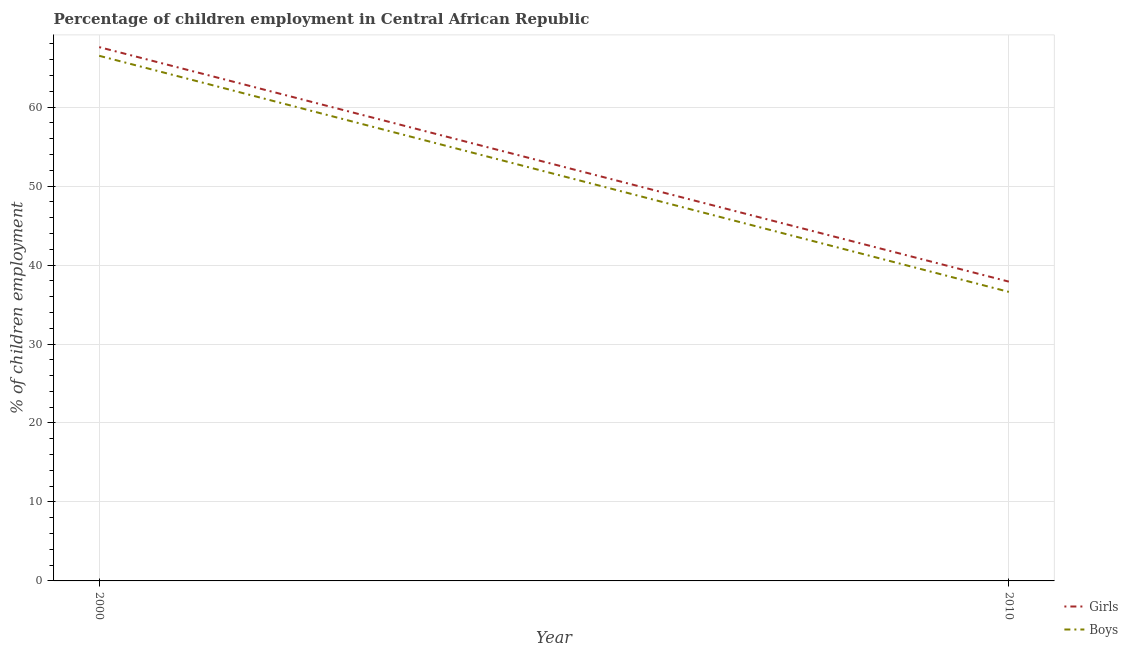How many different coloured lines are there?
Give a very brief answer. 2. Does the line corresponding to percentage of employed boys intersect with the line corresponding to percentage of employed girls?
Give a very brief answer. No. Is the number of lines equal to the number of legend labels?
Ensure brevity in your answer.  Yes. What is the percentage of employed boys in 2010?
Your answer should be very brief. 36.6. Across all years, what is the maximum percentage of employed boys?
Keep it short and to the point. 66.5. Across all years, what is the minimum percentage of employed boys?
Your response must be concise. 36.6. In which year was the percentage of employed boys maximum?
Offer a very short reply. 2000. In which year was the percentage of employed girls minimum?
Offer a very short reply. 2010. What is the total percentage of employed girls in the graph?
Provide a short and direct response. 105.5. What is the difference between the percentage of employed boys in 2000 and that in 2010?
Make the answer very short. 29.9. What is the difference between the percentage of employed girls in 2010 and the percentage of employed boys in 2000?
Your response must be concise. -28.6. What is the average percentage of employed girls per year?
Provide a succinct answer. 52.75. In the year 2010, what is the difference between the percentage of employed boys and percentage of employed girls?
Keep it short and to the point. -1.3. What is the ratio of the percentage of employed boys in 2000 to that in 2010?
Offer a very short reply. 1.82. Does the percentage of employed boys monotonically increase over the years?
Make the answer very short. No. How many years are there in the graph?
Give a very brief answer. 2. What is the difference between two consecutive major ticks on the Y-axis?
Offer a terse response. 10. Does the graph contain grids?
Offer a terse response. Yes. Where does the legend appear in the graph?
Keep it short and to the point. Bottom right. How many legend labels are there?
Provide a succinct answer. 2. What is the title of the graph?
Ensure brevity in your answer.  Percentage of children employment in Central African Republic. What is the label or title of the X-axis?
Provide a short and direct response. Year. What is the label or title of the Y-axis?
Offer a very short reply. % of children employment. What is the % of children employment of Girls in 2000?
Ensure brevity in your answer.  67.6. What is the % of children employment of Boys in 2000?
Provide a short and direct response. 66.5. What is the % of children employment of Girls in 2010?
Give a very brief answer. 37.9. What is the % of children employment in Boys in 2010?
Ensure brevity in your answer.  36.6. Across all years, what is the maximum % of children employment in Girls?
Keep it short and to the point. 67.6. Across all years, what is the maximum % of children employment of Boys?
Keep it short and to the point. 66.5. Across all years, what is the minimum % of children employment in Girls?
Ensure brevity in your answer.  37.9. Across all years, what is the minimum % of children employment in Boys?
Your answer should be compact. 36.6. What is the total % of children employment of Girls in the graph?
Keep it short and to the point. 105.5. What is the total % of children employment in Boys in the graph?
Your answer should be compact. 103.1. What is the difference between the % of children employment of Girls in 2000 and that in 2010?
Ensure brevity in your answer.  29.7. What is the difference between the % of children employment of Boys in 2000 and that in 2010?
Ensure brevity in your answer.  29.9. What is the average % of children employment in Girls per year?
Give a very brief answer. 52.75. What is the average % of children employment in Boys per year?
Give a very brief answer. 51.55. In the year 2000, what is the difference between the % of children employment in Girls and % of children employment in Boys?
Offer a terse response. 1.1. What is the ratio of the % of children employment in Girls in 2000 to that in 2010?
Ensure brevity in your answer.  1.78. What is the ratio of the % of children employment in Boys in 2000 to that in 2010?
Your answer should be compact. 1.82. What is the difference between the highest and the second highest % of children employment in Girls?
Your response must be concise. 29.7. What is the difference between the highest and the second highest % of children employment in Boys?
Offer a very short reply. 29.9. What is the difference between the highest and the lowest % of children employment of Girls?
Make the answer very short. 29.7. What is the difference between the highest and the lowest % of children employment in Boys?
Your answer should be compact. 29.9. 